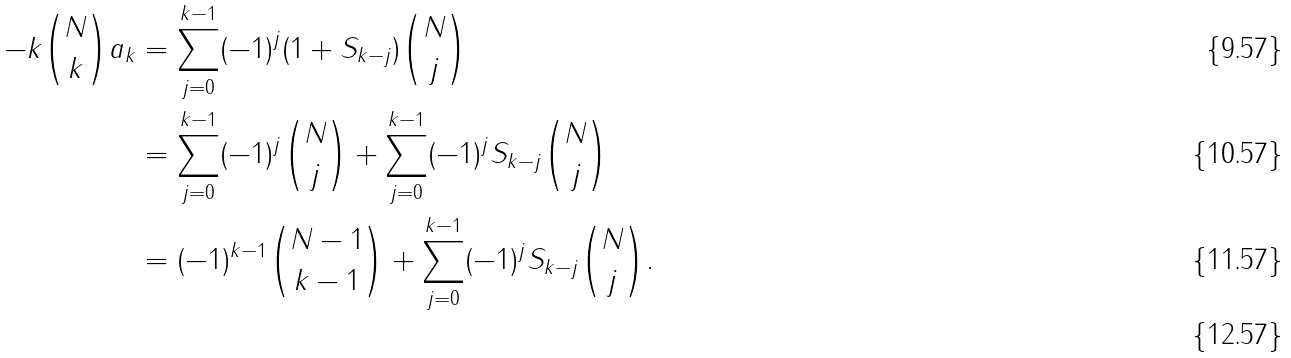Convert formula to latex. <formula><loc_0><loc_0><loc_500><loc_500>- k { N \choose k } a _ { k } & = \sum _ { j = 0 } ^ { k - 1 } ( - 1 ) ^ { j } ( 1 + S _ { k - j } ) { N \choose j } \\ & = \sum _ { j = 0 } ^ { k - 1 } ( - 1 ) ^ { j } { N \choose j } + \sum _ { j = 0 } ^ { k - 1 } ( - 1 ) ^ { j } S _ { k - j } { N \choose j } \\ & = ( - 1 ) ^ { k - 1 } { { N - 1 } \choose { k - 1 } } + \sum _ { j = 0 } ^ { k - 1 } ( - 1 ) ^ { j } S _ { k - j } { N \choose j } . \\</formula> 